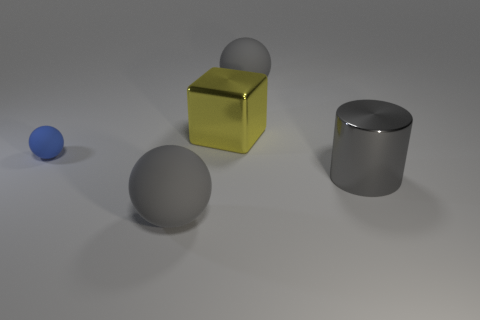Is there anything else that is the same size as the blue matte sphere?
Your answer should be compact. No. What number of other things are the same color as the tiny rubber thing?
Provide a succinct answer. 0. Does the yellow cube have the same material as the big cylinder that is in front of the yellow metallic thing?
Keep it short and to the point. Yes. There is a rubber sphere on the right side of the large yellow metallic thing on the right side of the small blue rubber ball; how many big matte balls are on the left side of it?
Provide a succinct answer. 1. Is the number of cubes on the left side of the tiny matte thing less than the number of gray balls that are to the left of the large yellow thing?
Your response must be concise. Yes. How many other objects are the same material as the blue thing?
Provide a succinct answer. 2. There is a cube that is the same size as the gray metal thing; what is it made of?
Provide a succinct answer. Metal. How many blue things are either blocks or matte things?
Ensure brevity in your answer.  1. There is a rubber sphere that is in front of the yellow block and on the right side of the blue rubber thing; what is its color?
Offer a very short reply. Gray. Is the large gray ball on the left side of the big yellow block made of the same material as the large gray object behind the big gray cylinder?
Your answer should be very brief. Yes. 